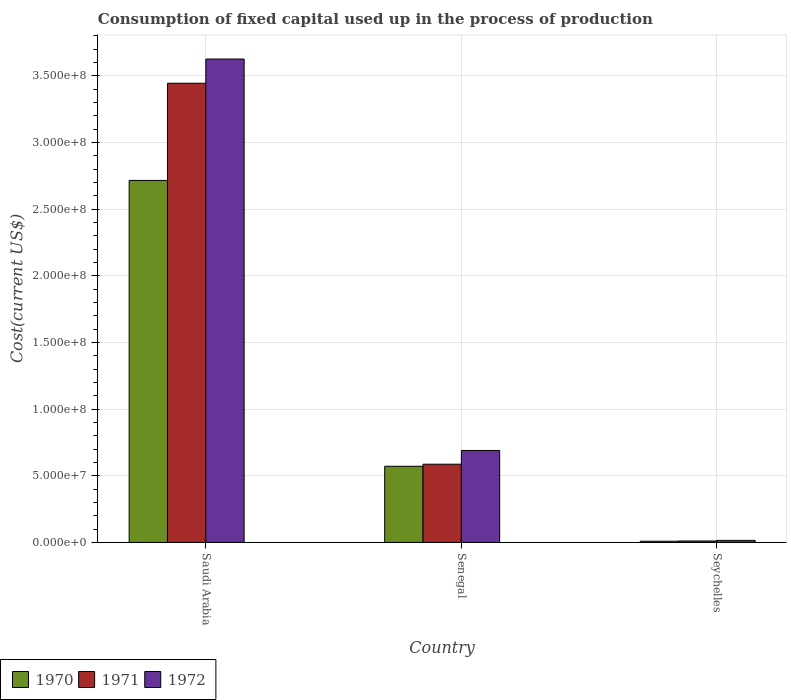How many different coloured bars are there?
Offer a very short reply. 3. Are the number of bars on each tick of the X-axis equal?
Your answer should be very brief. Yes. How many bars are there on the 2nd tick from the left?
Your response must be concise. 3. How many bars are there on the 2nd tick from the right?
Offer a very short reply. 3. What is the label of the 3rd group of bars from the left?
Your answer should be very brief. Seychelles. What is the amount consumed in the process of production in 1970 in Saudi Arabia?
Your answer should be very brief. 2.72e+08. Across all countries, what is the maximum amount consumed in the process of production in 1970?
Provide a short and direct response. 2.72e+08. Across all countries, what is the minimum amount consumed in the process of production in 1970?
Provide a succinct answer. 8.98e+05. In which country was the amount consumed in the process of production in 1972 maximum?
Offer a very short reply. Saudi Arabia. In which country was the amount consumed in the process of production in 1972 minimum?
Keep it short and to the point. Seychelles. What is the total amount consumed in the process of production in 1972 in the graph?
Your answer should be compact. 4.33e+08. What is the difference between the amount consumed in the process of production in 1972 in Saudi Arabia and that in Senegal?
Ensure brevity in your answer.  2.94e+08. What is the difference between the amount consumed in the process of production in 1971 in Seychelles and the amount consumed in the process of production in 1972 in Saudi Arabia?
Offer a terse response. -3.62e+08. What is the average amount consumed in the process of production in 1972 per country?
Give a very brief answer. 1.44e+08. What is the difference between the amount consumed in the process of production of/in 1971 and amount consumed in the process of production of/in 1970 in Seychelles?
Ensure brevity in your answer.  1.97e+05. What is the ratio of the amount consumed in the process of production in 1972 in Saudi Arabia to that in Senegal?
Make the answer very short. 5.26. What is the difference between the highest and the second highest amount consumed in the process of production in 1971?
Offer a very short reply. 5.76e+07. What is the difference between the highest and the lowest amount consumed in the process of production in 1972?
Offer a terse response. 3.61e+08. What is the difference between two consecutive major ticks on the Y-axis?
Offer a very short reply. 5.00e+07. Are the values on the major ticks of Y-axis written in scientific E-notation?
Ensure brevity in your answer.  Yes. Does the graph contain any zero values?
Offer a terse response. No. Where does the legend appear in the graph?
Make the answer very short. Bottom left. How many legend labels are there?
Your answer should be very brief. 3. How are the legend labels stacked?
Offer a terse response. Horizontal. What is the title of the graph?
Offer a terse response. Consumption of fixed capital used up in the process of production. What is the label or title of the X-axis?
Your answer should be compact. Country. What is the label or title of the Y-axis?
Offer a terse response. Cost(current US$). What is the Cost(current US$) of 1970 in Saudi Arabia?
Provide a short and direct response. 2.72e+08. What is the Cost(current US$) in 1971 in Saudi Arabia?
Provide a succinct answer. 3.44e+08. What is the Cost(current US$) in 1972 in Saudi Arabia?
Provide a succinct answer. 3.63e+08. What is the Cost(current US$) of 1970 in Senegal?
Your response must be concise. 5.71e+07. What is the Cost(current US$) in 1971 in Senegal?
Provide a succinct answer. 5.87e+07. What is the Cost(current US$) in 1972 in Senegal?
Your response must be concise. 6.90e+07. What is the Cost(current US$) in 1970 in Seychelles?
Provide a succinct answer. 8.98e+05. What is the Cost(current US$) in 1971 in Seychelles?
Your answer should be very brief. 1.09e+06. What is the Cost(current US$) of 1972 in Seychelles?
Provide a succinct answer. 1.54e+06. Across all countries, what is the maximum Cost(current US$) of 1970?
Your answer should be compact. 2.72e+08. Across all countries, what is the maximum Cost(current US$) of 1971?
Provide a short and direct response. 3.44e+08. Across all countries, what is the maximum Cost(current US$) in 1972?
Provide a succinct answer. 3.63e+08. Across all countries, what is the minimum Cost(current US$) in 1970?
Give a very brief answer. 8.98e+05. Across all countries, what is the minimum Cost(current US$) of 1971?
Your answer should be very brief. 1.09e+06. Across all countries, what is the minimum Cost(current US$) of 1972?
Your response must be concise. 1.54e+06. What is the total Cost(current US$) in 1970 in the graph?
Ensure brevity in your answer.  3.30e+08. What is the total Cost(current US$) in 1971 in the graph?
Provide a short and direct response. 4.04e+08. What is the total Cost(current US$) of 1972 in the graph?
Your answer should be very brief. 4.33e+08. What is the difference between the Cost(current US$) of 1970 in Saudi Arabia and that in Senegal?
Offer a terse response. 2.14e+08. What is the difference between the Cost(current US$) of 1971 in Saudi Arabia and that in Senegal?
Make the answer very short. 2.86e+08. What is the difference between the Cost(current US$) in 1972 in Saudi Arabia and that in Senegal?
Offer a very short reply. 2.94e+08. What is the difference between the Cost(current US$) of 1970 in Saudi Arabia and that in Seychelles?
Your answer should be very brief. 2.71e+08. What is the difference between the Cost(current US$) in 1971 in Saudi Arabia and that in Seychelles?
Your response must be concise. 3.43e+08. What is the difference between the Cost(current US$) of 1972 in Saudi Arabia and that in Seychelles?
Your answer should be compact. 3.61e+08. What is the difference between the Cost(current US$) in 1970 in Senegal and that in Seychelles?
Make the answer very short. 5.62e+07. What is the difference between the Cost(current US$) of 1971 in Senegal and that in Seychelles?
Provide a succinct answer. 5.76e+07. What is the difference between the Cost(current US$) of 1972 in Senegal and that in Seychelles?
Offer a terse response. 6.74e+07. What is the difference between the Cost(current US$) of 1970 in Saudi Arabia and the Cost(current US$) of 1971 in Senegal?
Your answer should be very brief. 2.13e+08. What is the difference between the Cost(current US$) of 1970 in Saudi Arabia and the Cost(current US$) of 1972 in Senegal?
Your answer should be compact. 2.03e+08. What is the difference between the Cost(current US$) in 1971 in Saudi Arabia and the Cost(current US$) in 1972 in Senegal?
Your response must be concise. 2.75e+08. What is the difference between the Cost(current US$) of 1970 in Saudi Arabia and the Cost(current US$) of 1971 in Seychelles?
Offer a terse response. 2.70e+08. What is the difference between the Cost(current US$) of 1970 in Saudi Arabia and the Cost(current US$) of 1972 in Seychelles?
Keep it short and to the point. 2.70e+08. What is the difference between the Cost(current US$) of 1971 in Saudi Arabia and the Cost(current US$) of 1972 in Seychelles?
Ensure brevity in your answer.  3.43e+08. What is the difference between the Cost(current US$) of 1970 in Senegal and the Cost(current US$) of 1971 in Seychelles?
Your answer should be compact. 5.60e+07. What is the difference between the Cost(current US$) of 1970 in Senegal and the Cost(current US$) of 1972 in Seychelles?
Your response must be concise. 5.56e+07. What is the difference between the Cost(current US$) in 1971 in Senegal and the Cost(current US$) in 1972 in Seychelles?
Offer a terse response. 5.72e+07. What is the average Cost(current US$) in 1970 per country?
Your response must be concise. 1.10e+08. What is the average Cost(current US$) of 1971 per country?
Make the answer very short. 1.35e+08. What is the average Cost(current US$) in 1972 per country?
Give a very brief answer. 1.44e+08. What is the difference between the Cost(current US$) of 1970 and Cost(current US$) of 1971 in Saudi Arabia?
Your answer should be compact. -7.29e+07. What is the difference between the Cost(current US$) of 1970 and Cost(current US$) of 1972 in Saudi Arabia?
Ensure brevity in your answer.  -9.11e+07. What is the difference between the Cost(current US$) of 1971 and Cost(current US$) of 1972 in Saudi Arabia?
Give a very brief answer. -1.81e+07. What is the difference between the Cost(current US$) in 1970 and Cost(current US$) in 1971 in Senegal?
Ensure brevity in your answer.  -1.55e+06. What is the difference between the Cost(current US$) in 1970 and Cost(current US$) in 1972 in Senegal?
Give a very brief answer. -1.18e+07. What is the difference between the Cost(current US$) of 1971 and Cost(current US$) of 1972 in Senegal?
Offer a very short reply. -1.03e+07. What is the difference between the Cost(current US$) of 1970 and Cost(current US$) of 1971 in Seychelles?
Give a very brief answer. -1.97e+05. What is the difference between the Cost(current US$) of 1970 and Cost(current US$) of 1972 in Seychelles?
Your response must be concise. -6.45e+05. What is the difference between the Cost(current US$) in 1971 and Cost(current US$) in 1972 in Seychelles?
Provide a short and direct response. -4.48e+05. What is the ratio of the Cost(current US$) in 1970 in Saudi Arabia to that in Senegal?
Make the answer very short. 4.75. What is the ratio of the Cost(current US$) in 1971 in Saudi Arabia to that in Senegal?
Your response must be concise. 5.87. What is the ratio of the Cost(current US$) in 1972 in Saudi Arabia to that in Senegal?
Provide a succinct answer. 5.26. What is the ratio of the Cost(current US$) in 1970 in Saudi Arabia to that in Seychelles?
Make the answer very short. 302.4. What is the ratio of the Cost(current US$) of 1971 in Saudi Arabia to that in Seychelles?
Your answer should be compact. 314.69. What is the ratio of the Cost(current US$) of 1972 in Saudi Arabia to that in Seychelles?
Provide a short and direct response. 235.06. What is the ratio of the Cost(current US$) of 1970 in Senegal to that in Seychelles?
Give a very brief answer. 63.63. What is the ratio of the Cost(current US$) in 1971 in Senegal to that in Seychelles?
Offer a terse response. 53.62. What is the ratio of the Cost(current US$) of 1972 in Senegal to that in Seychelles?
Your answer should be very brief. 44.72. What is the difference between the highest and the second highest Cost(current US$) of 1970?
Ensure brevity in your answer.  2.14e+08. What is the difference between the highest and the second highest Cost(current US$) of 1971?
Your answer should be compact. 2.86e+08. What is the difference between the highest and the second highest Cost(current US$) of 1972?
Offer a terse response. 2.94e+08. What is the difference between the highest and the lowest Cost(current US$) in 1970?
Provide a succinct answer. 2.71e+08. What is the difference between the highest and the lowest Cost(current US$) in 1971?
Offer a very short reply. 3.43e+08. What is the difference between the highest and the lowest Cost(current US$) in 1972?
Your response must be concise. 3.61e+08. 